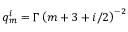Convert formula to latex. <formula><loc_0><loc_0><loc_500><loc_500>q _ { m } ^ { i } = \Gamma \left ( m + 3 + i / 2 \right ) ^ { - 2 }</formula> 